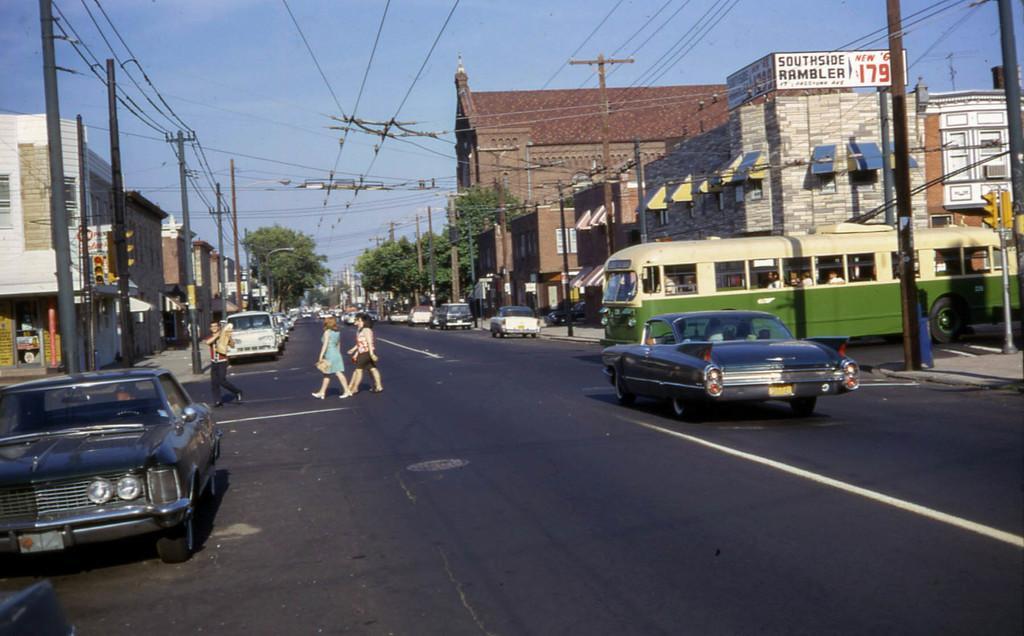How would you summarize this image in a sentence or two? Here in this picture we can see people walking on the road and we can also see number of cars present and on the right side we can see a bus present and beside the road on either side we can see number of houses present and we can also see electric poles present and we can see plants and trees present and we can see the sky is clear and we can also see traffic signal lights present on poles. 